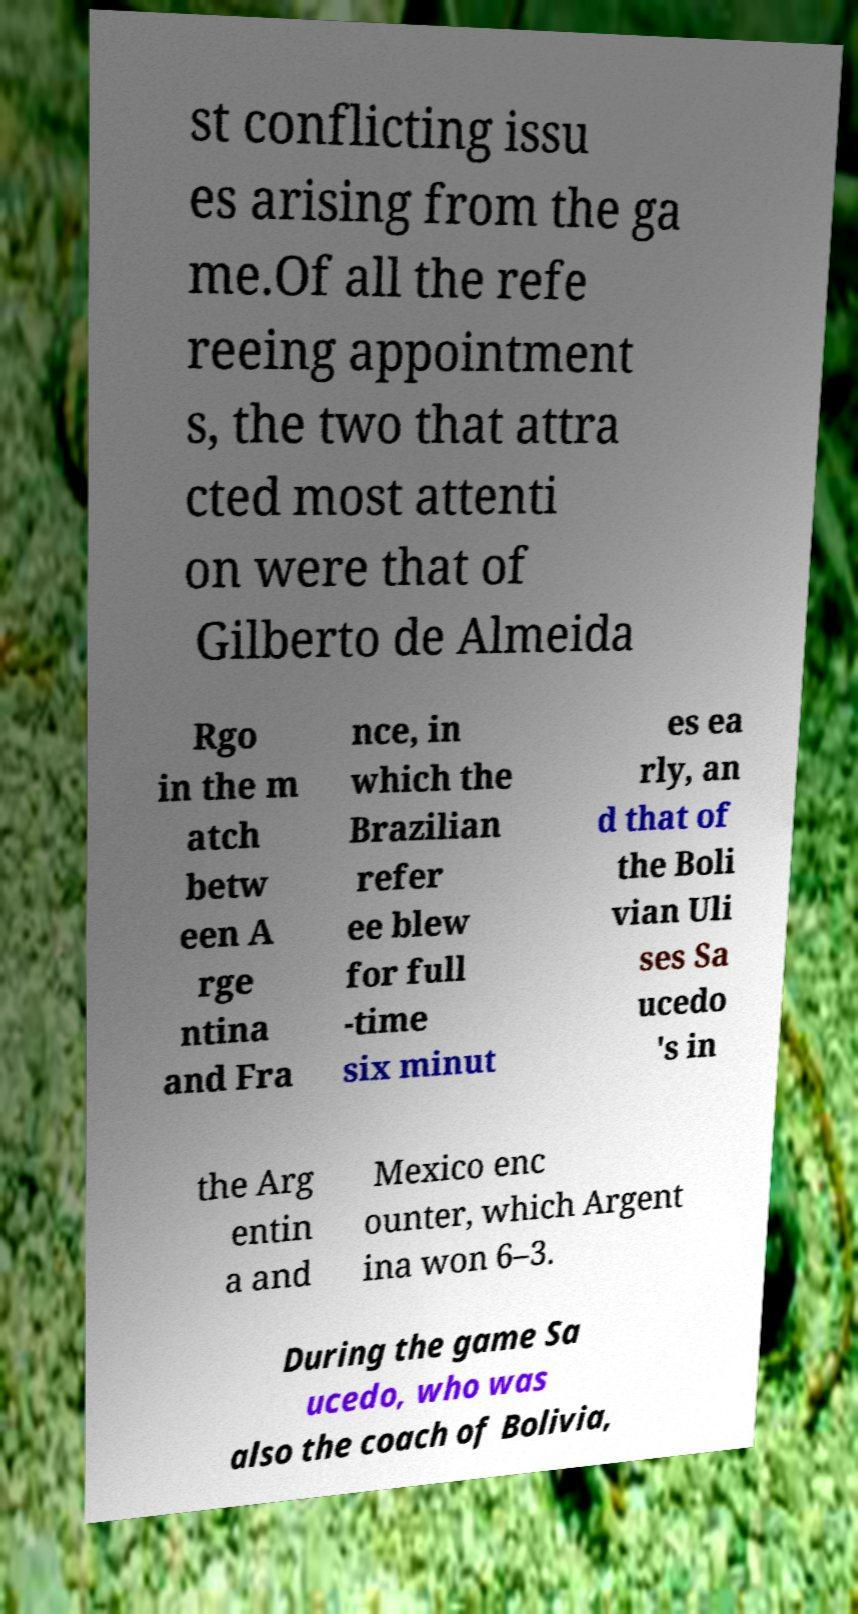Can you read and provide the text displayed in the image?This photo seems to have some interesting text. Can you extract and type it out for me? st conflicting issu es arising from the ga me.Of all the refe reeing appointment s, the two that attra cted most attenti on were that of Gilberto de Almeida Rgo in the m atch betw een A rge ntina and Fra nce, in which the Brazilian refer ee blew for full -time six minut es ea rly, an d that of the Boli vian Uli ses Sa ucedo 's in the Arg entin a and Mexico enc ounter, which Argent ina won 6–3. During the game Sa ucedo, who was also the coach of Bolivia, 